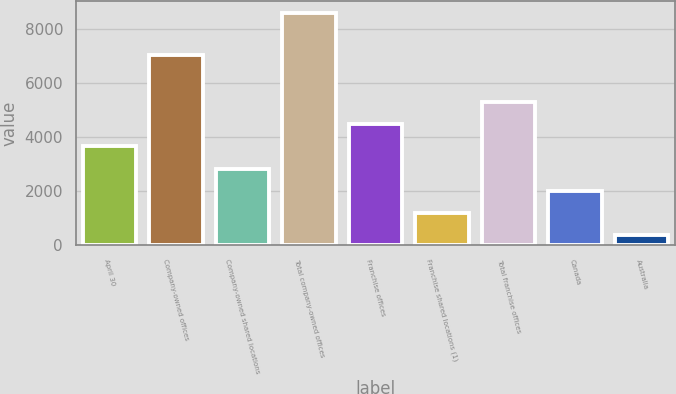<chart> <loc_0><loc_0><loc_500><loc_500><bar_chart><fcel>April 30<fcel>Company-owned offices<fcel>Company-owned shared locations<fcel>Total company-owned offices<fcel>Franchise offices<fcel>Franchise shared locations (1)<fcel>Total franchise offices<fcel>Canada<fcel>Australia<nl><fcel>3655.2<fcel>7029<fcel>2835.9<fcel>8571<fcel>4474.5<fcel>1197.3<fcel>5293.8<fcel>2016.6<fcel>378<nl></chart> 